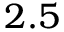<formula> <loc_0><loc_0><loc_500><loc_500>2 . 5</formula> 